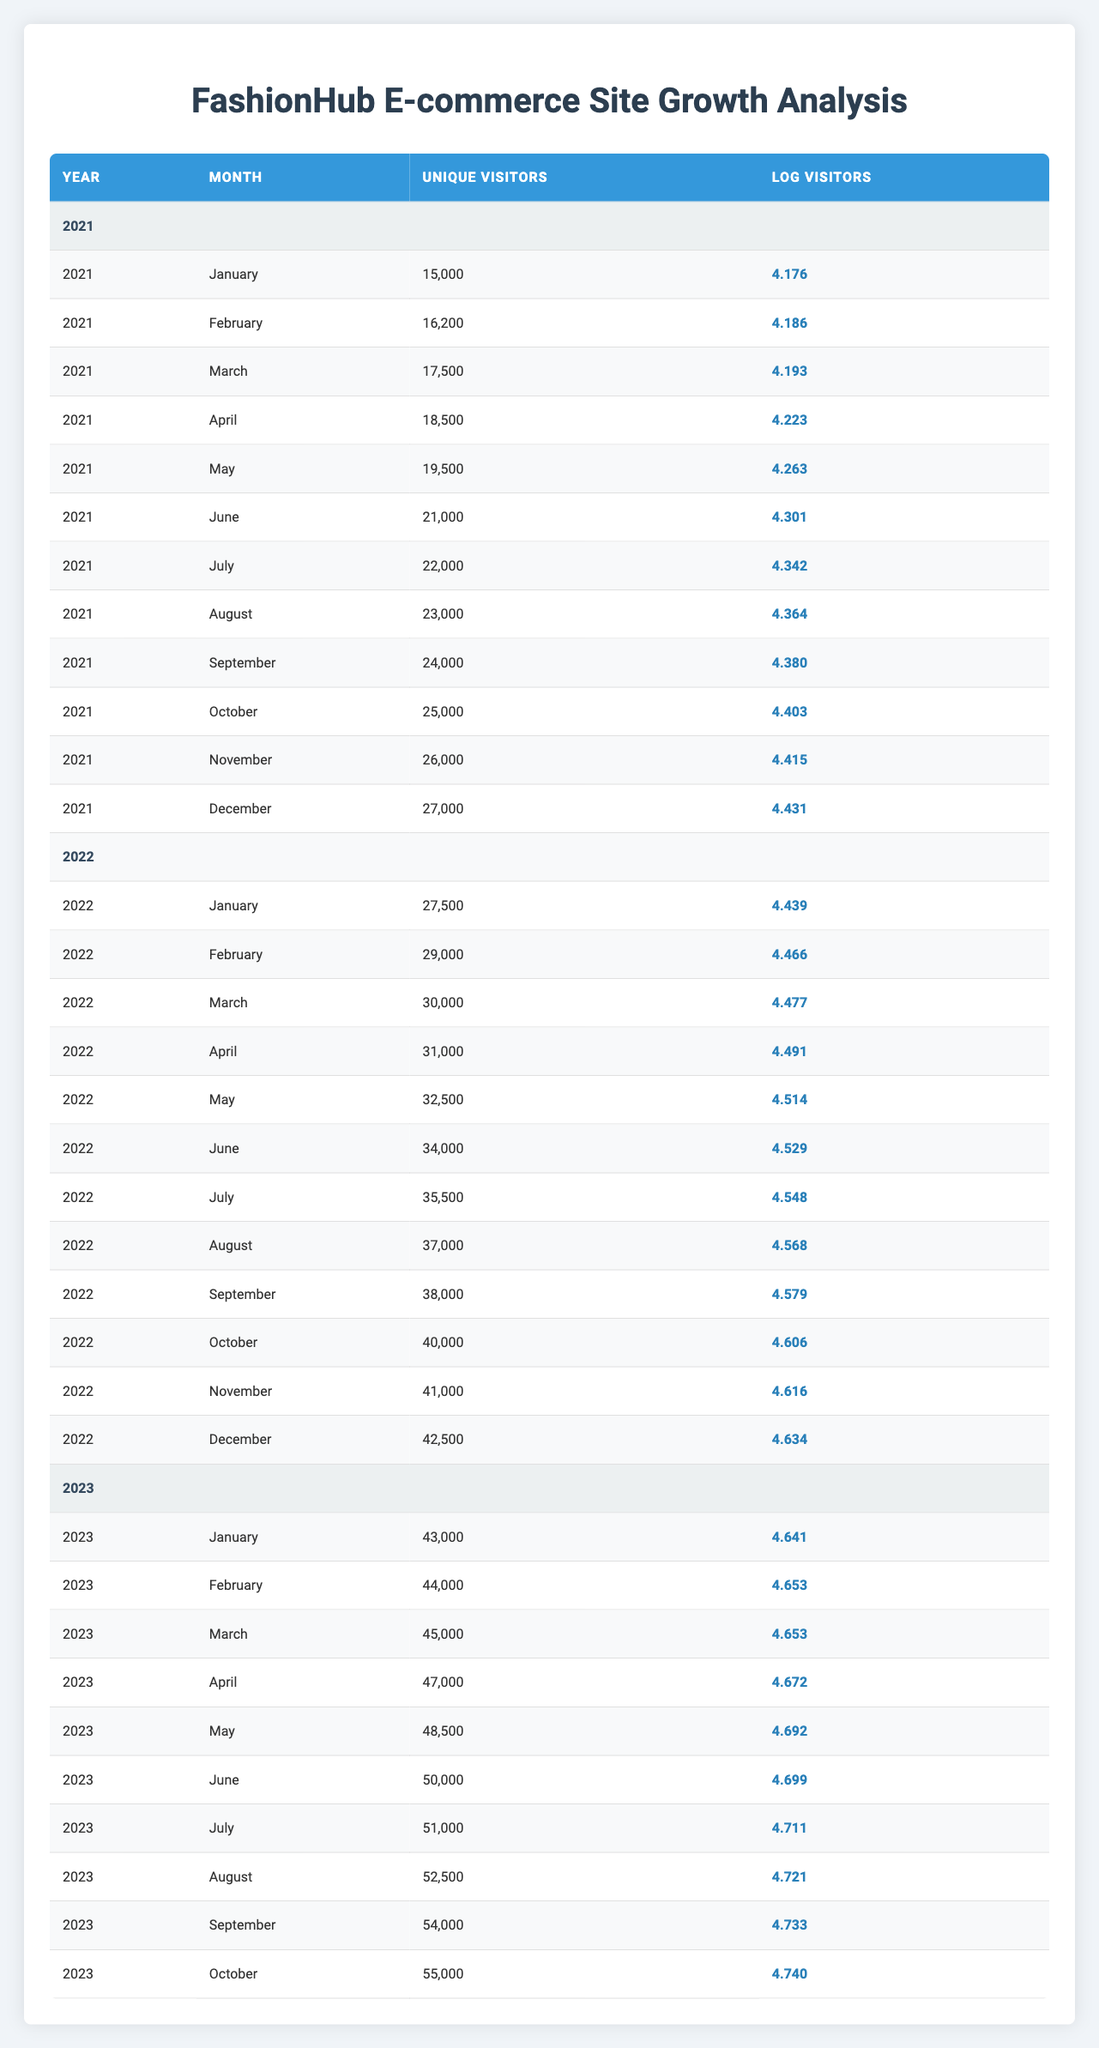What was the unique visitor count for FashionHub in December 2022? The table lists the unique visitors for each month and year. Looking at December 2022, the unique visitor count is clearly listed as 42,500.
Answer: 42,500 How many unique visitors did FashionHub have in March 2021? By checking the table for March 2021, the entry shows that the unique visitors were 17,500.
Answer: 17,500 What is the average number of unique visitors from January to June 2022? The unique visitors from January to June 2022 are: 27,500, 29,000, 30,000, 31,000, 32,500, and 34,000. There are six months, so the average is calculated by summing these values: 27,500 + 29,000 + 30,000 + 31,000 + 32,500 + 34,000 = 184,000, then dividing by 6 gives us 30,666.67.
Answer: 30,666.67 In which month of 2023 did FashionHub reach its highest number of unique visitors? By examining the unique visitor counts for each month in 2023, we see the highest value is in October 2023 with 55,000 visitors.
Answer: October Were there more unique visitors in July 2022 compared to July 2021? In July 2021, the unique visitor count was 22,000. In July 2022, the count was 35,500. Since 35,500 is greater than 22,000, the statement is true.
Answer: Yes What was the change in unique visitors from January to December in 2021? From the table, January 2021 had 15,000 unique visitors and December 2021 had 27,000. The change can be calculated as 27,000 - 15,000 = 12,000 visitors.
Answer: 12,000 What is the logarithmic value of unique visitors for May 2023? The logarithmic value corresponding to unique visitors for May 2023 is presented in the table, which indicates the value as 4.692.
Answer: 4.692 How many unique visitors did FashionHub gain from January to April 2021? In January 2021, there were 15,000 unique visitors and in April 2021, there were 18,500. To calculate the gain, we subtract: 18,500 - 15,000 = 3,500.
Answer: 3,500 What was the unique visitor count for August 2022 and June 2022, and which month had more visitors? August 2022 had 37,000 unique visitors, and June 2022 had 34,000. Since 37,000 is greater than 34,000, August 2022 had more visitors.
Answer: August 2022 had more visitors 